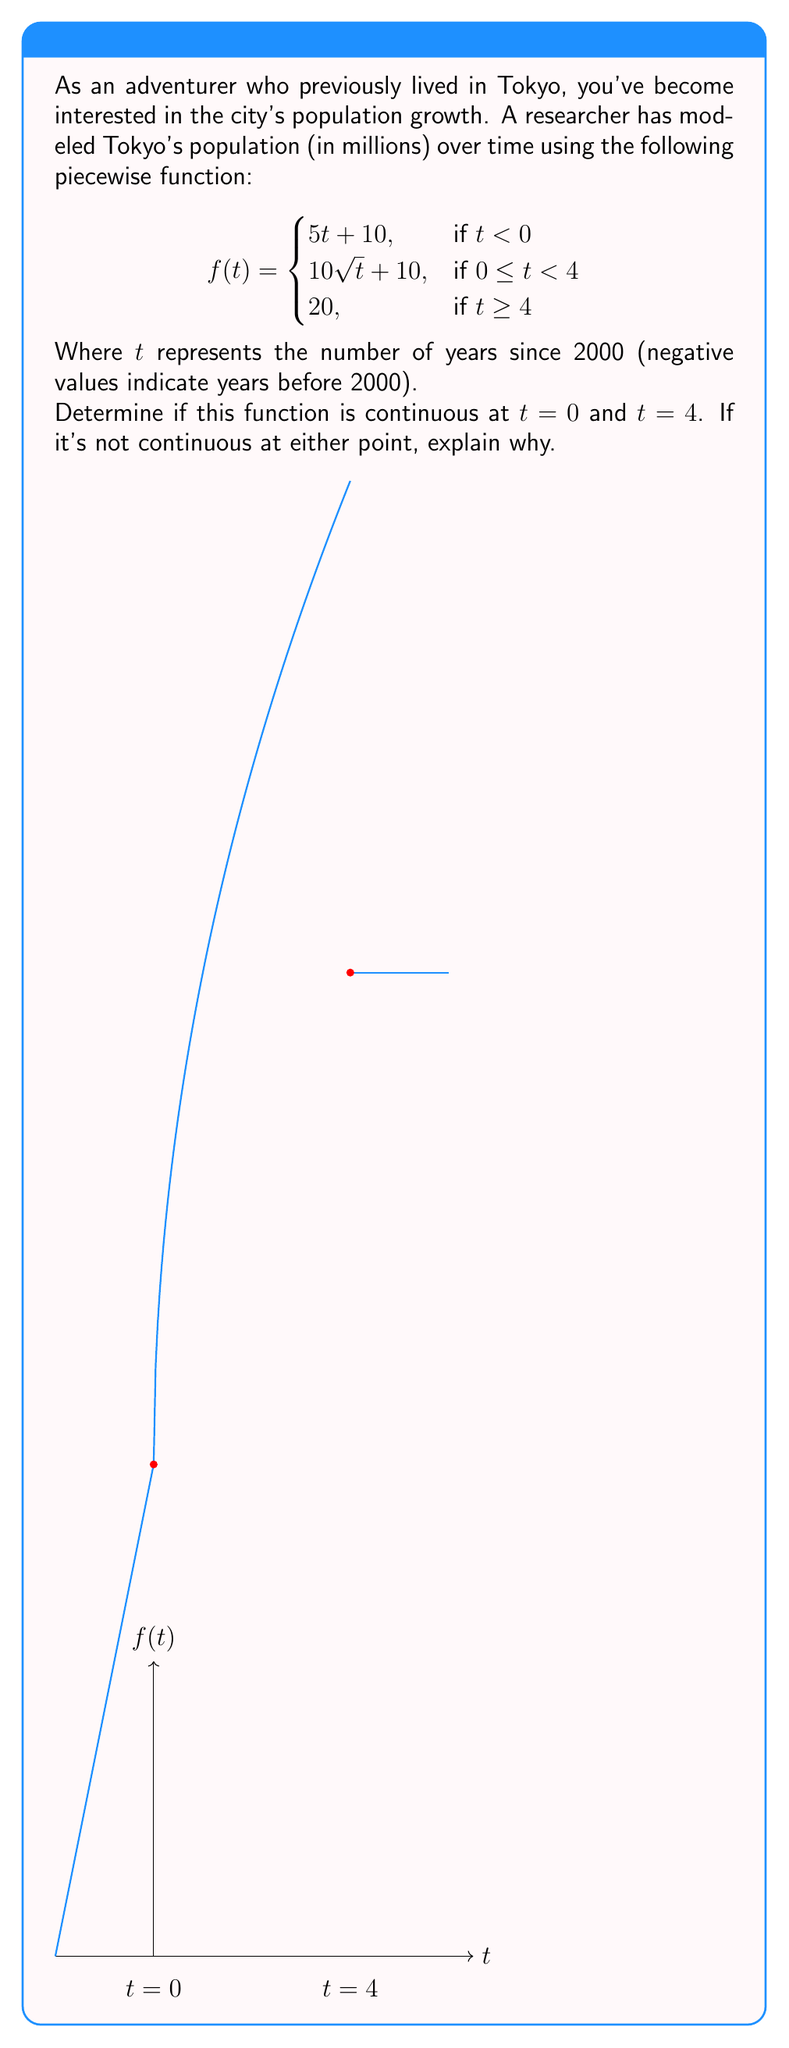What is the answer to this math problem? To determine if the function is continuous at $t = 0$ and $t = 4$, we need to check three conditions at each point:
1. The function is defined at the point
2. The limit of the function as we approach the point from both sides exists
3. The limit equals the function value at that point

For $t = 0$:
1. $f(0)$ is defined: $f(0) = 10\sqrt{0} + 10 = 10$
2. Left-hand limit: 
   $\lim_{t \to 0^-} f(t) = \lim_{t \to 0^-} (5t + 10) = 10$
   Right-hand limit:
   $\lim_{t \to 0^+} f(t) = \lim_{t \to 0^+} (10\sqrt{t} + 10) = 10$
3. Both limits equal $f(0) = 10$

Therefore, $f(t)$ is continuous at $t = 0$.

For $t = 4$:
1. $f(4)$ is defined: $f(4) = 20$
2. Left-hand limit:
   $\lim_{t \to 4^-} f(t) = \lim_{t \to 4^-} (10\sqrt{t} + 10) = 10\sqrt{4} + 10 = 30$
   Right-hand limit:
   $\lim_{t \to 4^+} f(t) = 20$
3. The left-hand limit (30) does not equal the right-hand limit (20) or $f(4)$

Therefore, $f(t)$ is not continuous at $t = 4$ due to a jump discontinuity.
Answer: Continuous at $t = 0$, discontinuous at $t = 4$ 